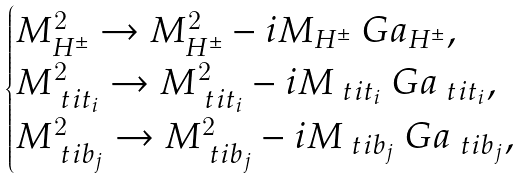Convert formula to latex. <formula><loc_0><loc_0><loc_500><loc_500>\begin{cases} M _ { H ^ { \pm } } ^ { 2 } \to M _ { H ^ { \pm } } ^ { 2 } - i M _ { H ^ { \pm } } \ G a _ { H ^ { \pm } } , \\ M ^ { 2 } _ { \ t i t _ { i } } \to M ^ { 2 } _ { \ t i t _ { i } } - i M _ { \ t i t _ { i } } \ G a _ { \ t i t _ { i } } , \\ M ^ { 2 } _ { \ t i b _ { j } } \to M ^ { 2 } _ { \ t i b _ { j } } - i M _ { \ t i b _ { j } } \ G a _ { \ t i b _ { j } } , \end{cases}</formula> 